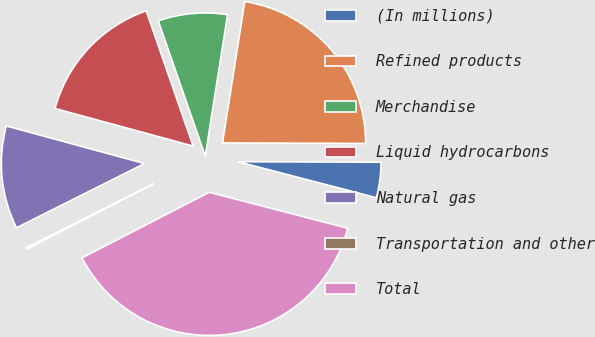<chart> <loc_0><loc_0><loc_500><loc_500><pie_chart><fcel>(In millions)<fcel>Refined products<fcel>Merchandise<fcel>Liquid hydrocarbons<fcel>Natural gas<fcel>Transportation and other<fcel>Total<nl><fcel>3.99%<fcel>22.57%<fcel>7.81%<fcel>15.45%<fcel>11.63%<fcel>0.17%<fcel>38.38%<nl></chart> 